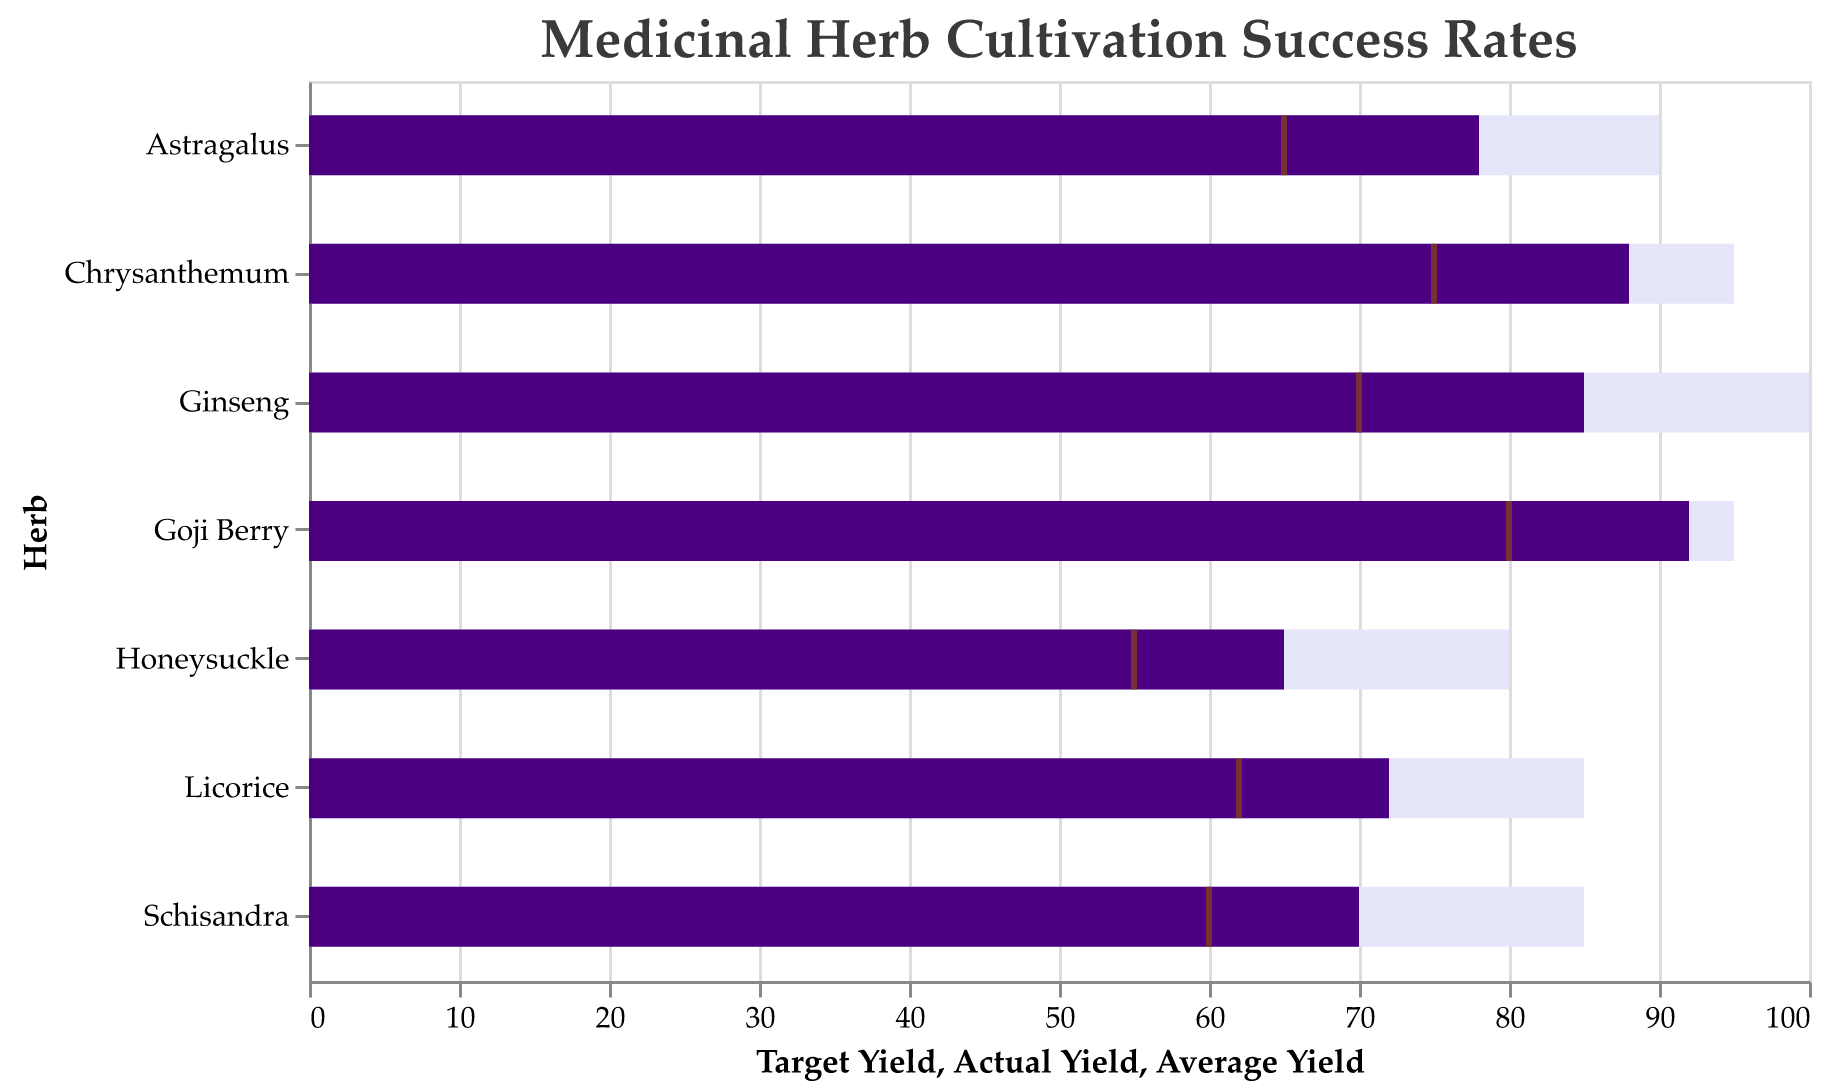What is the title of the figure? The title is usually displayed at the top of the figure. In this case, it is explicitly stated.
Answer: Medicinal Herb Cultivation Success Rates Which herb has the highest Actual Yield? By observing the length of the dark purple bars, the longest one corresponds to Goji Berry.
Answer: Goji Berry How close is Astragalus's Actual Yield to its Target Yield? Astragalus’s Actual Yield is 78, and its Target Yield is 90. Subtract the Actual Yield from the Target Yield to find the difference.
Answer: 12 Between Ginseng and Chrysanthemum, which herb has a smaller difference between Actual Yield and Average Yield? Ginseng’s Actual Yield is 85, and its Average Yield is 70, giving a difference of 15. Chrysanthemum’s Actual Yield is 88, and its Average Yield is 75, giving a difference of 13. Thus, Chrysanthemum has a smaller difference.
Answer: Chrysanthemum Comparing Honeysuckle and Licorice, which one falls short more significantly from its Target Yield? Honeysuckle’s Actual Yield is 65, and its Target Yield is 80, falling short by 15. Licorice’s Actual Yield is 72, and its Target Yield is 85, falling short by 13. Thus, Honeysuckle falls short more significantly.
Answer: Honeysuckle Which region has the herb with the highest Average Yield? By checking the position of the brown ticks, the highest tick corresponds to Goji Berry from Guangxi with an Average Yield of 80.
Answer: Guangxi What is the average Actual Yield of all herbs? Sum the Actual Yields (85 + 78 + 92 + 70 + 88 + 65 + 72) and divide by the number of herbs, which is 7: (85 + 78 + 92 + 70 + 88 + 65 + 72) / 7 = 550 / 7 ≈ 78.57.
Answer: 78.57 Which herb is grown in the Hubei region? The herb corresponding to Hubei can be found by matching the region and the herb names in the bullet chart.
Answer: Schisandra How many herbs have an Actual Yield equal to or greater than 80? Counting the herbs whose dark purple bar extends to or beyond the 80 mark, we find there are three: Ginseng, Goji Berry, and Chrysanthemum.
Answer: 3 Which herb's cultivation is closest to its Average Yield? The tick marks represent average yields. The herb with Actual Yield closest to its Average Yield, by visually comparing the purple bar length to the brown tick position, is Goji Berry.
Answer: Goji Berry 